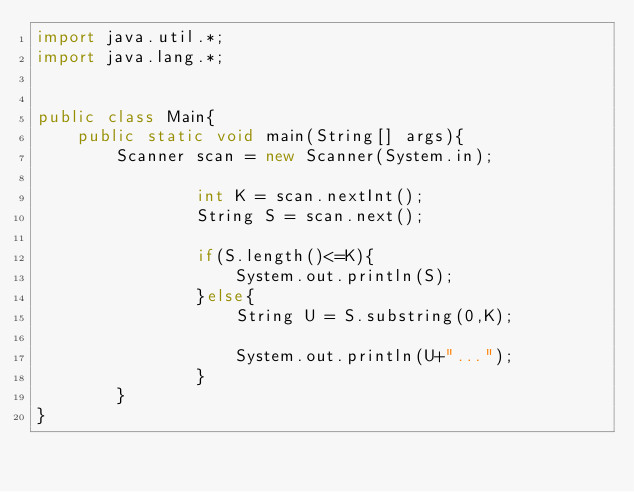Convert code to text. <code><loc_0><loc_0><loc_500><loc_500><_Java_>import java.util.*; 
import java.lang.*; 


public class Main{
	public static void main(String[] args){
		Scanner scan = new Scanner(System.in);
                
                int K = scan.nextInt();
                String S = scan.next();
                
                if(S.length()<=K){
                    System.out.println(S);
                }else{           
                    String U = S.substring(0,K);

                    System.out.println(U+"...");
                }
        }
}</code> 